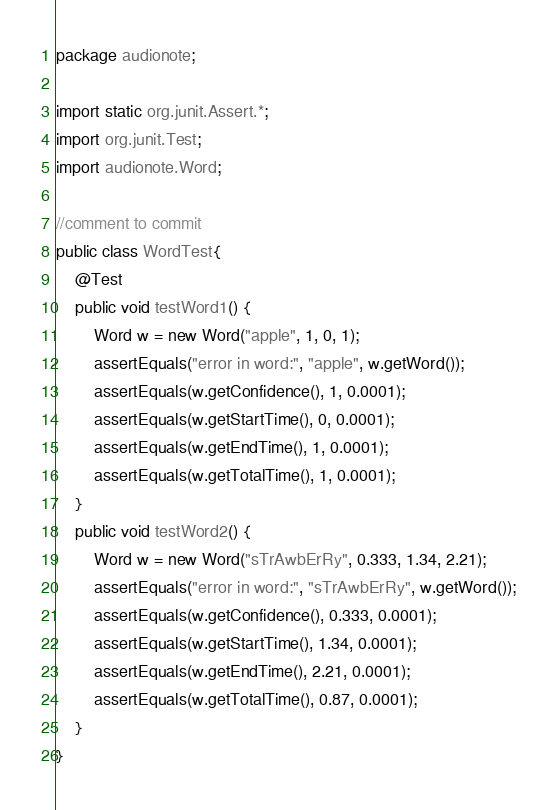<code> <loc_0><loc_0><loc_500><loc_500><_Java_>package audionote;

import static org.junit.Assert.*;
import org.junit.Test;
import audionote.Word;

//comment to commit
public class WordTest{
    @Test
    public void testWord1() {
        Word w = new Word("apple", 1, 0, 1);
        assertEquals("error in word:", "apple", w.getWord());
        assertEquals(w.getConfidence(), 1, 0.0001);
        assertEquals(w.getStartTime(), 0, 0.0001);
        assertEquals(w.getEndTime(), 1, 0.0001);
        assertEquals(w.getTotalTime(), 1, 0.0001);
    }
    public void testWord2() {
        Word w = new Word("sTrAwbErRy", 0.333, 1.34, 2.21);
        assertEquals("error in word:", "sTrAwbErRy", w.getWord());
        assertEquals(w.getConfidence(), 0.333, 0.0001);
        assertEquals(w.getStartTime(), 1.34, 0.0001);
        assertEquals(w.getEndTime(), 2.21, 0.0001);
        assertEquals(w.getTotalTime(), 0.87, 0.0001);
    }
}
</code> 